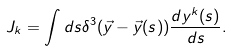Convert formula to latex. <formula><loc_0><loc_0><loc_500><loc_500>J _ { k } = \int d s \delta ^ { 3 } ( \vec { y } - \vec { y } ( s ) ) \frac { d y ^ { k } ( s ) } { d s } .</formula> 